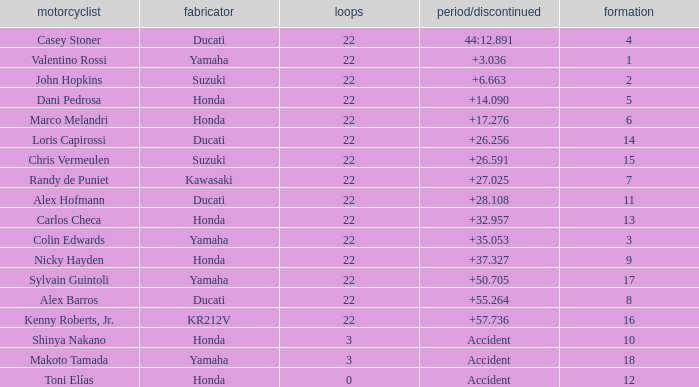What is the average grid for the competitiors who had laps smaller than 3? 12.0. 